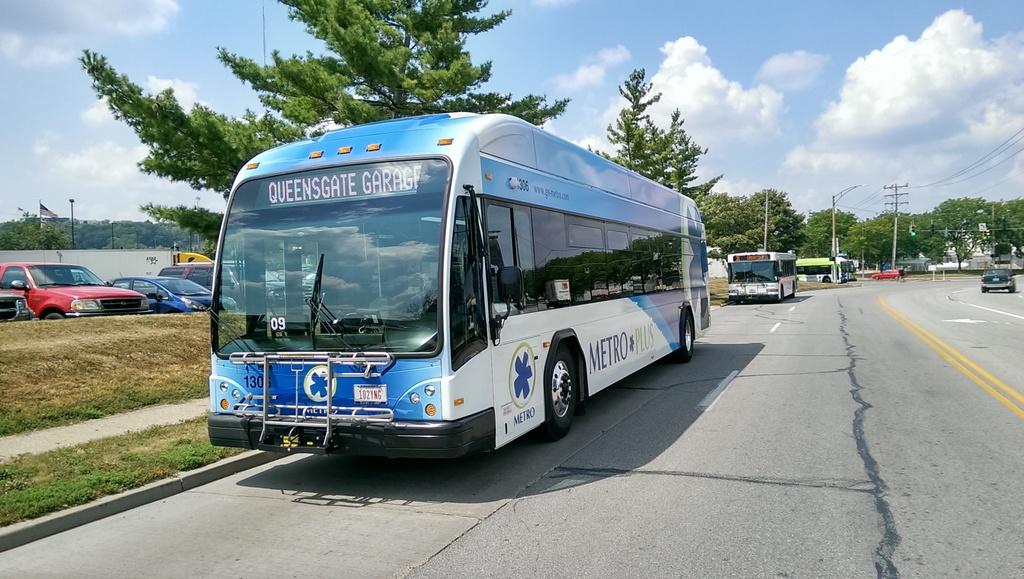Where is the bus headed?
Your answer should be compact. Queensgate garage. Where is this bus going?
Offer a terse response. Queensgate garage. 